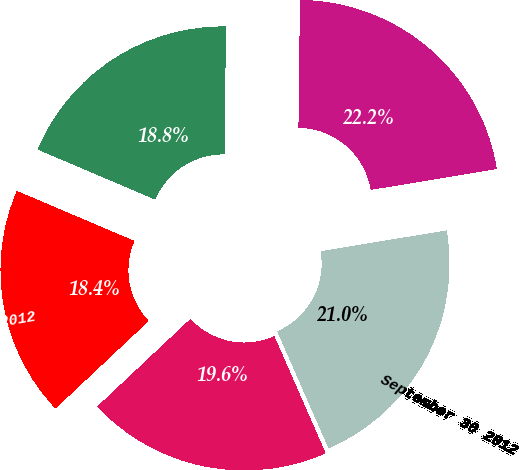<chart> <loc_0><loc_0><loc_500><loc_500><pie_chart><fcel>December 31 2012<fcel>September 30 2012<fcel>June 30 2012<fcel>March 31 2012<fcel>December 31 2011<nl><fcel>22.2%<fcel>21.03%<fcel>19.57%<fcel>18.4%<fcel>18.78%<nl></chart> 